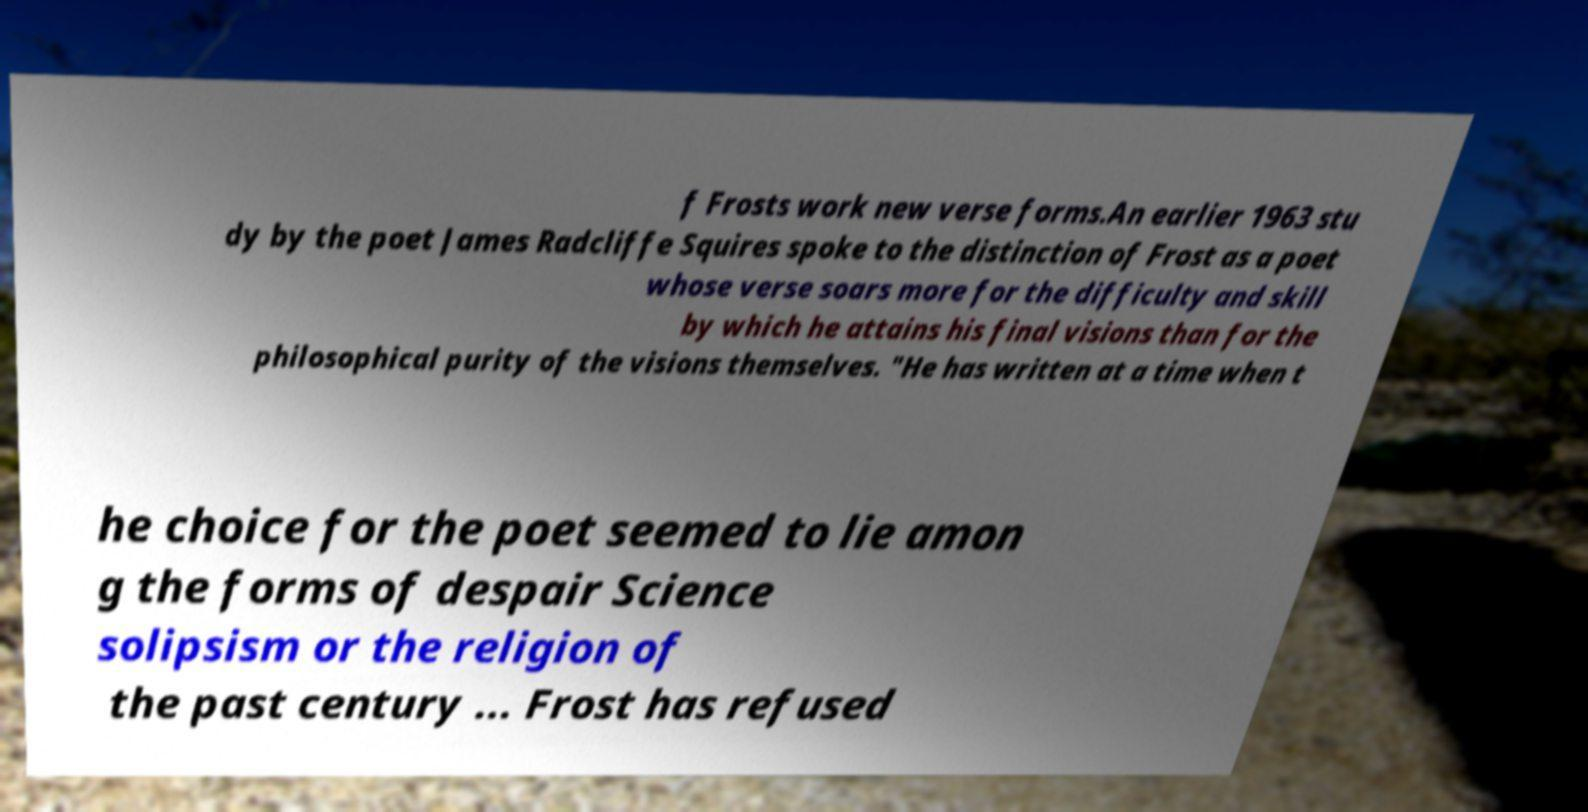Please read and relay the text visible in this image. What does it say? f Frosts work new verse forms.An earlier 1963 stu dy by the poet James Radcliffe Squires spoke to the distinction of Frost as a poet whose verse soars more for the difficulty and skill by which he attains his final visions than for the philosophical purity of the visions themselves. "He has written at a time when t he choice for the poet seemed to lie amon g the forms of despair Science solipsism or the religion of the past century ... Frost has refused 